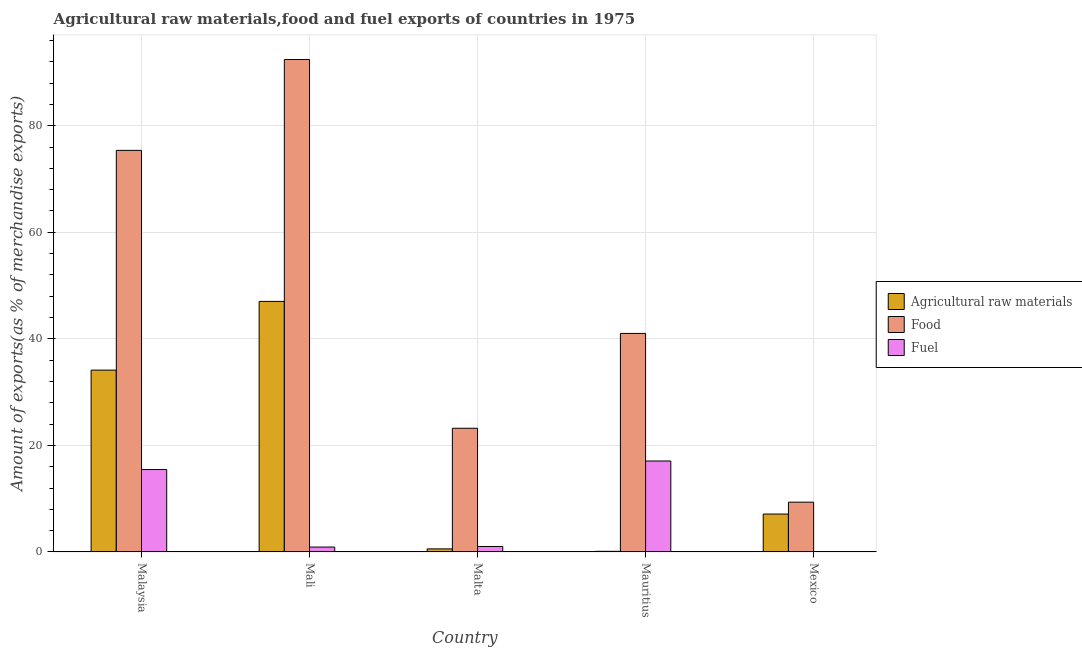How many different coloured bars are there?
Keep it short and to the point. 3. How many groups of bars are there?
Provide a short and direct response. 5. Are the number of bars per tick equal to the number of legend labels?
Make the answer very short. Yes. Are the number of bars on each tick of the X-axis equal?
Give a very brief answer. Yes. What is the label of the 5th group of bars from the left?
Your answer should be compact. Mexico. What is the percentage of raw materials exports in Malta?
Give a very brief answer. 0.58. Across all countries, what is the maximum percentage of food exports?
Make the answer very short. 92.42. Across all countries, what is the minimum percentage of fuel exports?
Make the answer very short. 0.07. In which country was the percentage of food exports maximum?
Keep it short and to the point. Mali. What is the total percentage of fuel exports in the graph?
Offer a terse response. 34.55. What is the difference between the percentage of raw materials exports in Mauritius and that in Mexico?
Offer a very short reply. -7. What is the difference between the percentage of raw materials exports in Malaysia and the percentage of fuel exports in Mali?
Keep it short and to the point. 33.21. What is the average percentage of raw materials exports per country?
Offer a very short reply. 17.79. What is the difference between the percentage of food exports and percentage of fuel exports in Mauritius?
Provide a short and direct response. 23.94. In how many countries, is the percentage of raw materials exports greater than 12 %?
Provide a short and direct response. 2. What is the ratio of the percentage of fuel exports in Mali to that in Mexico?
Your answer should be compact. 12.53. Is the difference between the percentage of fuel exports in Mali and Mexico greater than the difference between the percentage of food exports in Mali and Mexico?
Ensure brevity in your answer.  No. What is the difference between the highest and the second highest percentage of food exports?
Give a very brief answer. 17.06. What is the difference between the highest and the lowest percentage of raw materials exports?
Your response must be concise. 46.91. In how many countries, is the percentage of food exports greater than the average percentage of food exports taken over all countries?
Make the answer very short. 2. Is the sum of the percentage of food exports in Mali and Mexico greater than the maximum percentage of raw materials exports across all countries?
Your answer should be compact. Yes. What does the 3rd bar from the left in Mali represents?
Your response must be concise. Fuel. What does the 3rd bar from the right in Mauritius represents?
Give a very brief answer. Agricultural raw materials. How many bars are there?
Offer a very short reply. 15. Are all the bars in the graph horizontal?
Offer a very short reply. No. How many countries are there in the graph?
Give a very brief answer. 5. What is the difference between two consecutive major ticks on the Y-axis?
Your response must be concise. 20. What is the title of the graph?
Provide a succinct answer. Agricultural raw materials,food and fuel exports of countries in 1975. What is the label or title of the Y-axis?
Your answer should be compact. Amount of exports(as % of merchandise exports). What is the Amount of exports(as % of merchandise exports) in Agricultural raw materials in Malaysia?
Provide a succinct answer. 34.13. What is the Amount of exports(as % of merchandise exports) of Food in Malaysia?
Give a very brief answer. 75.37. What is the Amount of exports(as % of merchandise exports) in Fuel in Malaysia?
Provide a short and direct response. 15.46. What is the Amount of exports(as % of merchandise exports) of Agricultural raw materials in Mali?
Offer a very short reply. 47.02. What is the Amount of exports(as % of merchandise exports) of Food in Mali?
Make the answer very short. 92.42. What is the Amount of exports(as % of merchandise exports) in Fuel in Mali?
Your answer should be very brief. 0.92. What is the Amount of exports(as % of merchandise exports) of Agricultural raw materials in Malta?
Offer a terse response. 0.58. What is the Amount of exports(as % of merchandise exports) in Food in Malta?
Give a very brief answer. 23.21. What is the Amount of exports(as % of merchandise exports) in Fuel in Malta?
Provide a short and direct response. 1.02. What is the Amount of exports(as % of merchandise exports) of Agricultural raw materials in Mauritius?
Make the answer very short. 0.12. What is the Amount of exports(as % of merchandise exports) in Food in Mauritius?
Ensure brevity in your answer.  41.01. What is the Amount of exports(as % of merchandise exports) in Fuel in Mauritius?
Make the answer very short. 17.07. What is the Amount of exports(as % of merchandise exports) in Agricultural raw materials in Mexico?
Offer a very short reply. 7.11. What is the Amount of exports(as % of merchandise exports) in Food in Mexico?
Your answer should be very brief. 9.34. What is the Amount of exports(as % of merchandise exports) of Fuel in Mexico?
Your answer should be compact. 0.07. Across all countries, what is the maximum Amount of exports(as % of merchandise exports) in Agricultural raw materials?
Your response must be concise. 47.02. Across all countries, what is the maximum Amount of exports(as % of merchandise exports) in Food?
Your response must be concise. 92.42. Across all countries, what is the maximum Amount of exports(as % of merchandise exports) of Fuel?
Offer a terse response. 17.07. Across all countries, what is the minimum Amount of exports(as % of merchandise exports) of Agricultural raw materials?
Offer a terse response. 0.12. Across all countries, what is the minimum Amount of exports(as % of merchandise exports) of Food?
Provide a succinct answer. 9.34. Across all countries, what is the minimum Amount of exports(as % of merchandise exports) of Fuel?
Your answer should be compact. 0.07. What is the total Amount of exports(as % of merchandise exports) of Agricultural raw materials in the graph?
Your response must be concise. 88.96. What is the total Amount of exports(as % of merchandise exports) in Food in the graph?
Your response must be concise. 241.36. What is the total Amount of exports(as % of merchandise exports) in Fuel in the graph?
Provide a short and direct response. 34.55. What is the difference between the Amount of exports(as % of merchandise exports) of Agricultural raw materials in Malaysia and that in Mali?
Offer a terse response. -12.9. What is the difference between the Amount of exports(as % of merchandise exports) of Food in Malaysia and that in Mali?
Your answer should be very brief. -17.06. What is the difference between the Amount of exports(as % of merchandise exports) in Fuel in Malaysia and that in Mali?
Make the answer very short. 14.55. What is the difference between the Amount of exports(as % of merchandise exports) of Agricultural raw materials in Malaysia and that in Malta?
Offer a very short reply. 33.55. What is the difference between the Amount of exports(as % of merchandise exports) of Food in Malaysia and that in Malta?
Make the answer very short. 52.15. What is the difference between the Amount of exports(as % of merchandise exports) of Fuel in Malaysia and that in Malta?
Provide a succinct answer. 14.44. What is the difference between the Amount of exports(as % of merchandise exports) of Agricultural raw materials in Malaysia and that in Mauritius?
Your answer should be very brief. 34.01. What is the difference between the Amount of exports(as % of merchandise exports) of Food in Malaysia and that in Mauritius?
Make the answer very short. 34.35. What is the difference between the Amount of exports(as % of merchandise exports) of Fuel in Malaysia and that in Mauritius?
Make the answer very short. -1.61. What is the difference between the Amount of exports(as % of merchandise exports) of Agricultural raw materials in Malaysia and that in Mexico?
Ensure brevity in your answer.  27.01. What is the difference between the Amount of exports(as % of merchandise exports) of Food in Malaysia and that in Mexico?
Offer a terse response. 66.02. What is the difference between the Amount of exports(as % of merchandise exports) in Fuel in Malaysia and that in Mexico?
Give a very brief answer. 15.39. What is the difference between the Amount of exports(as % of merchandise exports) in Agricultural raw materials in Mali and that in Malta?
Provide a succinct answer. 46.45. What is the difference between the Amount of exports(as % of merchandise exports) in Food in Mali and that in Malta?
Your answer should be compact. 69.21. What is the difference between the Amount of exports(as % of merchandise exports) of Fuel in Mali and that in Malta?
Ensure brevity in your answer.  -0.11. What is the difference between the Amount of exports(as % of merchandise exports) of Agricultural raw materials in Mali and that in Mauritius?
Provide a succinct answer. 46.91. What is the difference between the Amount of exports(as % of merchandise exports) in Food in Mali and that in Mauritius?
Your response must be concise. 51.41. What is the difference between the Amount of exports(as % of merchandise exports) in Fuel in Mali and that in Mauritius?
Provide a succinct answer. -16.15. What is the difference between the Amount of exports(as % of merchandise exports) in Agricultural raw materials in Mali and that in Mexico?
Your answer should be very brief. 39.91. What is the difference between the Amount of exports(as % of merchandise exports) of Food in Mali and that in Mexico?
Your response must be concise. 83.08. What is the difference between the Amount of exports(as % of merchandise exports) in Fuel in Mali and that in Mexico?
Keep it short and to the point. 0.85. What is the difference between the Amount of exports(as % of merchandise exports) of Agricultural raw materials in Malta and that in Mauritius?
Offer a terse response. 0.46. What is the difference between the Amount of exports(as % of merchandise exports) in Food in Malta and that in Mauritius?
Your answer should be very brief. -17.8. What is the difference between the Amount of exports(as % of merchandise exports) of Fuel in Malta and that in Mauritius?
Offer a terse response. -16.05. What is the difference between the Amount of exports(as % of merchandise exports) in Agricultural raw materials in Malta and that in Mexico?
Keep it short and to the point. -6.54. What is the difference between the Amount of exports(as % of merchandise exports) in Food in Malta and that in Mexico?
Give a very brief answer. 13.87. What is the difference between the Amount of exports(as % of merchandise exports) in Fuel in Malta and that in Mexico?
Your answer should be compact. 0.95. What is the difference between the Amount of exports(as % of merchandise exports) in Agricultural raw materials in Mauritius and that in Mexico?
Give a very brief answer. -7. What is the difference between the Amount of exports(as % of merchandise exports) of Food in Mauritius and that in Mexico?
Provide a succinct answer. 31.67. What is the difference between the Amount of exports(as % of merchandise exports) of Fuel in Mauritius and that in Mexico?
Your response must be concise. 17. What is the difference between the Amount of exports(as % of merchandise exports) of Agricultural raw materials in Malaysia and the Amount of exports(as % of merchandise exports) of Food in Mali?
Your answer should be compact. -58.3. What is the difference between the Amount of exports(as % of merchandise exports) of Agricultural raw materials in Malaysia and the Amount of exports(as % of merchandise exports) of Fuel in Mali?
Your answer should be compact. 33.21. What is the difference between the Amount of exports(as % of merchandise exports) of Food in Malaysia and the Amount of exports(as % of merchandise exports) of Fuel in Mali?
Your answer should be very brief. 74.45. What is the difference between the Amount of exports(as % of merchandise exports) of Agricultural raw materials in Malaysia and the Amount of exports(as % of merchandise exports) of Food in Malta?
Offer a very short reply. 10.91. What is the difference between the Amount of exports(as % of merchandise exports) in Agricultural raw materials in Malaysia and the Amount of exports(as % of merchandise exports) in Fuel in Malta?
Provide a short and direct response. 33.1. What is the difference between the Amount of exports(as % of merchandise exports) in Food in Malaysia and the Amount of exports(as % of merchandise exports) in Fuel in Malta?
Provide a succinct answer. 74.34. What is the difference between the Amount of exports(as % of merchandise exports) of Agricultural raw materials in Malaysia and the Amount of exports(as % of merchandise exports) of Food in Mauritius?
Ensure brevity in your answer.  -6.88. What is the difference between the Amount of exports(as % of merchandise exports) of Agricultural raw materials in Malaysia and the Amount of exports(as % of merchandise exports) of Fuel in Mauritius?
Offer a very short reply. 17.06. What is the difference between the Amount of exports(as % of merchandise exports) of Food in Malaysia and the Amount of exports(as % of merchandise exports) of Fuel in Mauritius?
Ensure brevity in your answer.  58.29. What is the difference between the Amount of exports(as % of merchandise exports) in Agricultural raw materials in Malaysia and the Amount of exports(as % of merchandise exports) in Food in Mexico?
Provide a short and direct response. 24.78. What is the difference between the Amount of exports(as % of merchandise exports) in Agricultural raw materials in Malaysia and the Amount of exports(as % of merchandise exports) in Fuel in Mexico?
Give a very brief answer. 34.05. What is the difference between the Amount of exports(as % of merchandise exports) in Food in Malaysia and the Amount of exports(as % of merchandise exports) in Fuel in Mexico?
Your answer should be compact. 75.29. What is the difference between the Amount of exports(as % of merchandise exports) in Agricultural raw materials in Mali and the Amount of exports(as % of merchandise exports) in Food in Malta?
Your response must be concise. 23.81. What is the difference between the Amount of exports(as % of merchandise exports) of Agricultural raw materials in Mali and the Amount of exports(as % of merchandise exports) of Fuel in Malta?
Provide a succinct answer. 46. What is the difference between the Amount of exports(as % of merchandise exports) of Food in Mali and the Amount of exports(as % of merchandise exports) of Fuel in Malta?
Your answer should be compact. 91.4. What is the difference between the Amount of exports(as % of merchandise exports) in Agricultural raw materials in Mali and the Amount of exports(as % of merchandise exports) in Food in Mauritius?
Provide a short and direct response. 6.01. What is the difference between the Amount of exports(as % of merchandise exports) in Agricultural raw materials in Mali and the Amount of exports(as % of merchandise exports) in Fuel in Mauritius?
Provide a short and direct response. 29.95. What is the difference between the Amount of exports(as % of merchandise exports) of Food in Mali and the Amount of exports(as % of merchandise exports) of Fuel in Mauritius?
Offer a very short reply. 75.35. What is the difference between the Amount of exports(as % of merchandise exports) in Agricultural raw materials in Mali and the Amount of exports(as % of merchandise exports) in Food in Mexico?
Your response must be concise. 37.68. What is the difference between the Amount of exports(as % of merchandise exports) of Agricultural raw materials in Mali and the Amount of exports(as % of merchandise exports) of Fuel in Mexico?
Offer a very short reply. 46.95. What is the difference between the Amount of exports(as % of merchandise exports) in Food in Mali and the Amount of exports(as % of merchandise exports) in Fuel in Mexico?
Keep it short and to the point. 92.35. What is the difference between the Amount of exports(as % of merchandise exports) of Agricultural raw materials in Malta and the Amount of exports(as % of merchandise exports) of Food in Mauritius?
Offer a very short reply. -40.44. What is the difference between the Amount of exports(as % of merchandise exports) of Agricultural raw materials in Malta and the Amount of exports(as % of merchandise exports) of Fuel in Mauritius?
Your answer should be compact. -16.5. What is the difference between the Amount of exports(as % of merchandise exports) of Food in Malta and the Amount of exports(as % of merchandise exports) of Fuel in Mauritius?
Your response must be concise. 6.14. What is the difference between the Amount of exports(as % of merchandise exports) of Agricultural raw materials in Malta and the Amount of exports(as % of merchandise exports) of Food in Mexico?
Offer a terse response. -8.77. What is the difference between the Amount of exports(as % of merchandise exports) of Agricultural raw materials in Malta and the Amount of exports(as % of merchandise exports) of Fuel in Mexico?
Your answer should be compact. 0.5. What is the difference between the Amount of exports(as % of merchandise exports) of Food in Malta and the Amount of exports(as % of merchandise exports) of Fuel in Mexico?
Provide a succinct answer. 23.14. What is the difference between the Amount of exports(as % of merchandise exports) in Agricultural raw materials in Mauritius and the Amount of exports(as % of merchandise exports) in Food in Mexico?
Provide a short and direct response. -9.22. What is the difference between the Amount of exports(as % of merchandise exports) in Agricultural raw materials in Mauritius and the Amount of exports(as % of merchandise exports) in Fuel in Mexico?
Your answer should be very brief. 0.04. What is the difference between the Amount of exports(as % of merchandise exports) in Food in Mauritius and the Amount of exports(as % of merchandise exports) in Fuel in Mexico?
Provide a short and direct response. 40.94. What is the average Amount of exports(as % of merchandise exports) of Agricultural raw materials per country?
Your answer should be very brief. 17.79. What is the average Amount of exports(as % of merchandise exports) in Food per country?
Provide a short and direct response. 48.27. What is the average Amount of exports(as % of merchandise exports) of Fuel per country?
Offer a terse response. 6.91. What is the difference between the Amount of exports(as % of merchandise exports) in Agricultural raw materials and Amount of exports(as % of merchandise exports) in Food in Malaysia?
Keep it short and to the point. -41.24. What is the difference between the Amount of exports(as % of merchandise exports) in Agricultural raw materials and Amount of exports(as % of merchandise exports) in Fuel in Malaysia?
Make the answer very short. 18.66. What is the difference between the Amount of exports(as % of merchandise exports) in Food and Amount of exports(as % of merchandise exports) in Fuel in Malaysia?
Make the answer very short. 59.9. What is the difference between the Amount of exports(as % of merchandise exports) of Agricultural raw materials and Amount of exports(as % of merchandise exports) of Food in Mali?
Ensure brevity in your answer.  -45.4. What is the difference between the Amount of exports(as % of merchandise exports) in Agricultural raw materials and Amount of exports(as % of merchandise exports) in Fuel in Mali?
Offer a terse response. 46.1. What is the difference between the Amount of exports(as % of merchandise exports) in Food and Amount of exports(as % of merchandise exports) in Fuel in Mali?
Make the answer very short. 91.51. What is the difference between the Amount of exports(as % of merchandise exports) in Agricultural raw materials and Amount of exports(as % of merchandise exports) in Food in Malta?
Your response must be concise. -22.64. What is the difference between the Amount of exports(as % of merchandise exports) of Agricultural raw materials and Amount of exports(as % of merchandise exports) of Fuel in Malta?
Offer a very short reply. -0.45. What is the difference between the Amount of exports(as % of merchandise exports) of Food and Amount of exports(as % of merchandise exports) of Fuel in Malta?
Keep it short and to the point. 22.19. What is the difference between the Amount of exports(as % of merchandise exports) of Agricultural raw materials and Amount of exports(as % of merchandise exports) of Food in Mauritius?
Offer a terse response. -40.89. What is the difference between the Amount of exports(as % of merchandise exports) of Agricultural raw materials and Amount of exports(as % of merchandise exports) of Fuel in Mauritius?
Ensure brevity in your answer.  -16.95. What is the difference between the Amount of exports(as % of merchandise exports) of Food and Amount of exports(as % of merchandise exports) of Fuel in Mauritius?
Give a very brief answer. 23.94. What is the difference between the Amount of exports(as % of merchandise exports) in Agricultural raw materials and Amount of exports(as % of merchandise exports) in Food in Mexico?
Provide a succinct answer. -2.23. What is the difference between the Amount of exports(as % of merchandise exports) of Agricultural raw materials and Amount of exports(as % of merchandise exports) of Fuel in Mexico?
Give a very brief answer. 7.04. What is the difference between the Amount of exports(as % of merchandise exports) of Food and Amount of exports(as % of merchandise exports) of Fuel in Mexico?
Ensure brevity in your answer.  9.27. What is the ratio of the Amount of exports(as % of merchandise exports) of Agricultural raw materials in Malaysia to that in Mali?
Your answer should be compact. 0.73. What is the ratio of the Amount of exports(as % of merchandise exports) of Food in Malaysia to that in Mali?
Offer a terse response. 0.82. What is the ratio of the Amount of exports(as % of merchandise exports) of Fuel in Malaysia to that in Mali?
Ensure brevity in your answer.  16.84. What is the ratio of the Amount of exports(as % of merchandise exports) in Agricultural raw materials in Malaysia to that in Malta?
Provide a succinct answer. 59.28. What is the ratio of the Amount of exports(as % of merchandise exports) in Food in Malaysia to that in Malta?
Keep it short and to the point. 3.25. What is the ratio of the Amount of exports(as % of merchandise exports) of Fuel in Malaysia to that in Malta?
Provide a short and direct response. 15.1. What is the ratio of the Amount of exports(as % of merchandise exports) of Agricultural raw materials in Malaysia to that in Mauritius?
Ensure brevity in your answer.  288.86. What is the ratio of the Amount of exports(as % of merchandise exports) in Food in Malaysia to that in Mauritius?
Provide a succinct answer. 1.84. What is the ratio of the Amount of exports(as % of merchandise exports) in Fuel in Malaysia to that in Mauritius?
Your response must be concise. 0.91. What is the ratio of the Amount of exports(as % of merchandise exports) in Agricultural raw materials in Malaysia to that in Mexico?
Provide a succinct answer. 4.8. What is the ratio of the Amount of exports(as % of merchandise exports) in Food in Malaysia to that in Mexico?
Offer a very short reply. 8.07. What is the ratio of the Amount of exports(as % of merchandise exports) of Fuel in Malaysia to that in Mexico?
Offer a terse response. 210.9. What is the ratio of the Amount of exports(as % of merchandise exports) of Agricultural raw materials in Mali to that in Malta?
Make the answer very short. 81.69. What is the ratio of the Amount of exports(as % of merchandise exports) of Food in Mali to that in Malta?
Give a very brief answer. 3.98. What is the ratio of the Amount of exports(as % of merchandise exports) of Fuel in Mali to that in Malta?
Offer a very short reply. 0.9. What is the ratio of the Amount of exports(as % of merchandise exports) in Agricultural raw materials in Mali to that in Mauritius?
Provide a short and direct response. 398.02. What is the ratio of the Amount of exports(as % of merchandise exports) of Food in Mali to that in Mauritius?
Your response must be concise. 2.25. What is the ratio of the Amount of exports(as % of merchandise exports) in Fuel in Mali to that in Mauritius?
Your answer should be compact. 0.05. What is the ratio of the Amount of exports(as % of merchandise exports) in Agricultural raw materials in Mali to that in Mexico?
Provide a short and direct response. 6.61. What is the ratio of the Amount of exports(as % of merchandise exports) of Food in Mali to that in Mexico?
Provide a short and direct response. 9.89. What is the ratio of the Amount of exports(as % of merchandise exports) of Fuel in Mali to that in Mexico?
Your answer should be very brief. 12.53. What is the ratio of the Amount of exports(as % of merchandise exports) in Agricultural raw materials in Malta to that in Mauritius?
Your answer should be compact. 4.87. What is the ratio of the Amount of exports(as % of merchandise exports) of Food in Malta to that in Mauritius?
Give a very brief answer. 0.57. What is the ratio of the Amount of exports(as % of merchandise exports) in Agricultural raw materials in Malta to that in Mexico?
Your answer should be compact. 0.08. What is the ratio of the Amount of exports(as % of merchandise exports) of Food in Malta to that in Mexico?
Your answer should be compact. 2.48. What is the ratio of the Amount of exports(as % of merchandise exports) of Fuel in Malta to that in Mexico?
Your answer should be compact. 13.97. What is the ratio of the Amount of exports(as % of merchandise exports) of Agricultural raw materials in Mauritius to that in Mexico?
Your answer should be compact. 0.02. What is the ratio of the Amount of exports(as % of merchandise exports) in Food in Mauritius to that in Mexico?
Ensure brevity in your answer.  4.39. What is the ratio of the Amount of exports(as % of merchandise exports) of Fuel in Mauritius to that in Mexico?
Offer a very short reply. 232.81. What is the difference between the highest and the second highest Amount of exports(as % of merchandise exports) of Agricultural raw materials?
Offer a very short reply. 12.9. What is the difference between the highest and the second highest Amount of exports(as % of merchandise exports) in Food?
Keep it short and to the point. 17.06. What is the difference between the highest and the second highest Amount of exports(as % of merchandise exports) of Fuel?
Your answer should be compact. 1.61. What is the difference between the highest and the lowest Amount of exports(as % of merchandise exports) in Agricultural raw materials?
Provide a short and direct response. 46.91. What is the difference between the highest and the lowest Amount of exports(as % of merchandise exports) in Food?
Your answer should be compact. 83.08. What is the difference between the highest and the lowest Amount of exports(as % of merchandise exports) of Fuel?
Ensure brevity in your answer.  17. 